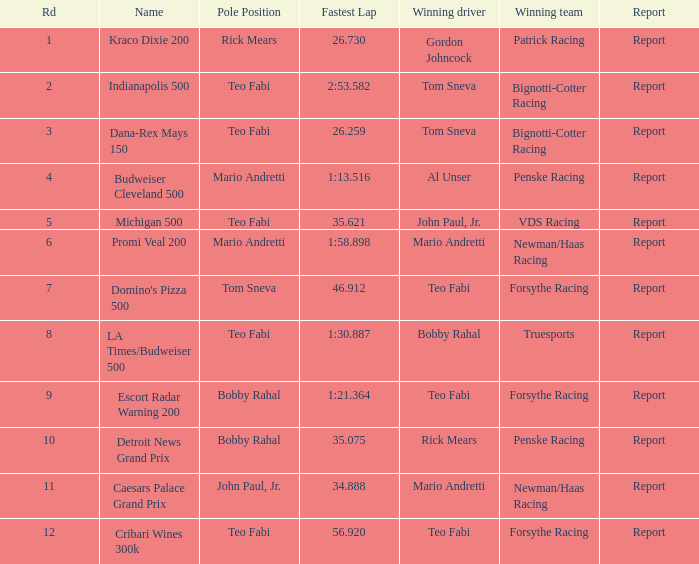How many winning drivers were there in the race that had a fastest lap time of 56.920? 1.0. 